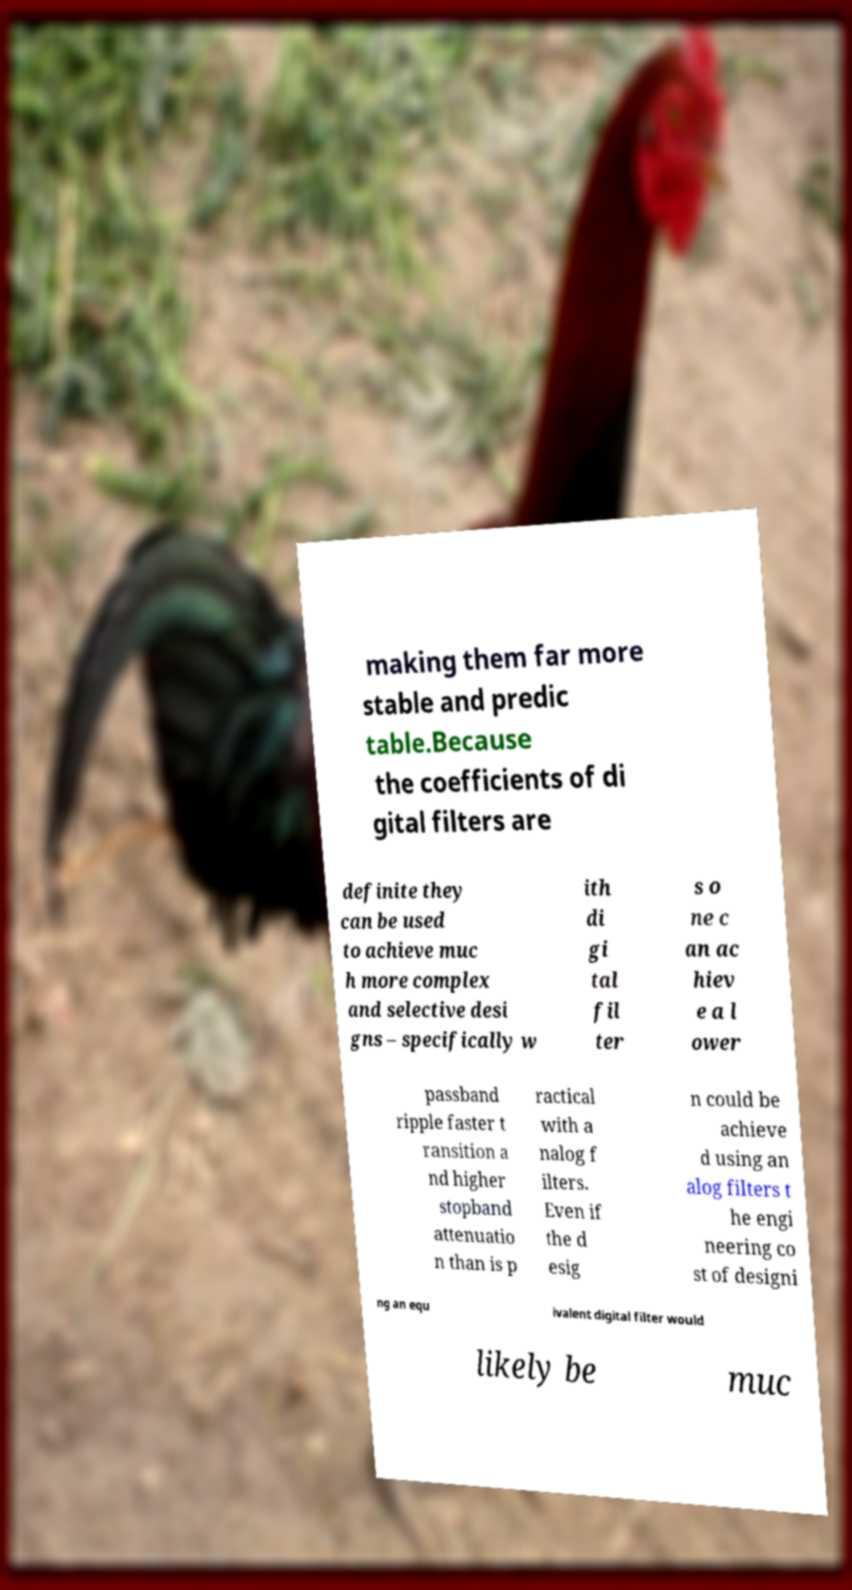Please identify and transcribe the text found in this image. making them far more stable and predic table.Because the coefficients of di gital filters are definite they can be used to achieve muc h more complex and selective desi gns – specifically w ith di gi tal fil ter s o ne c an ac hiev e a l ower passband ripple faster t ransition a nd higher stopband attenuatio n than is p ractical with a nalog f ilters. Even if the d esig n could be achieve d using an alog filters t he engi neering co st of designi ng an equ ivalent digital filter would likely be muc 